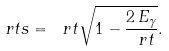<formula> <loc_0><loc_0><loc_500><loc_500>\ r t s = \ r t \sqrt { 1 - \frac { 2 \, E _ { \gamma } } { \ r t } } .</formula> 